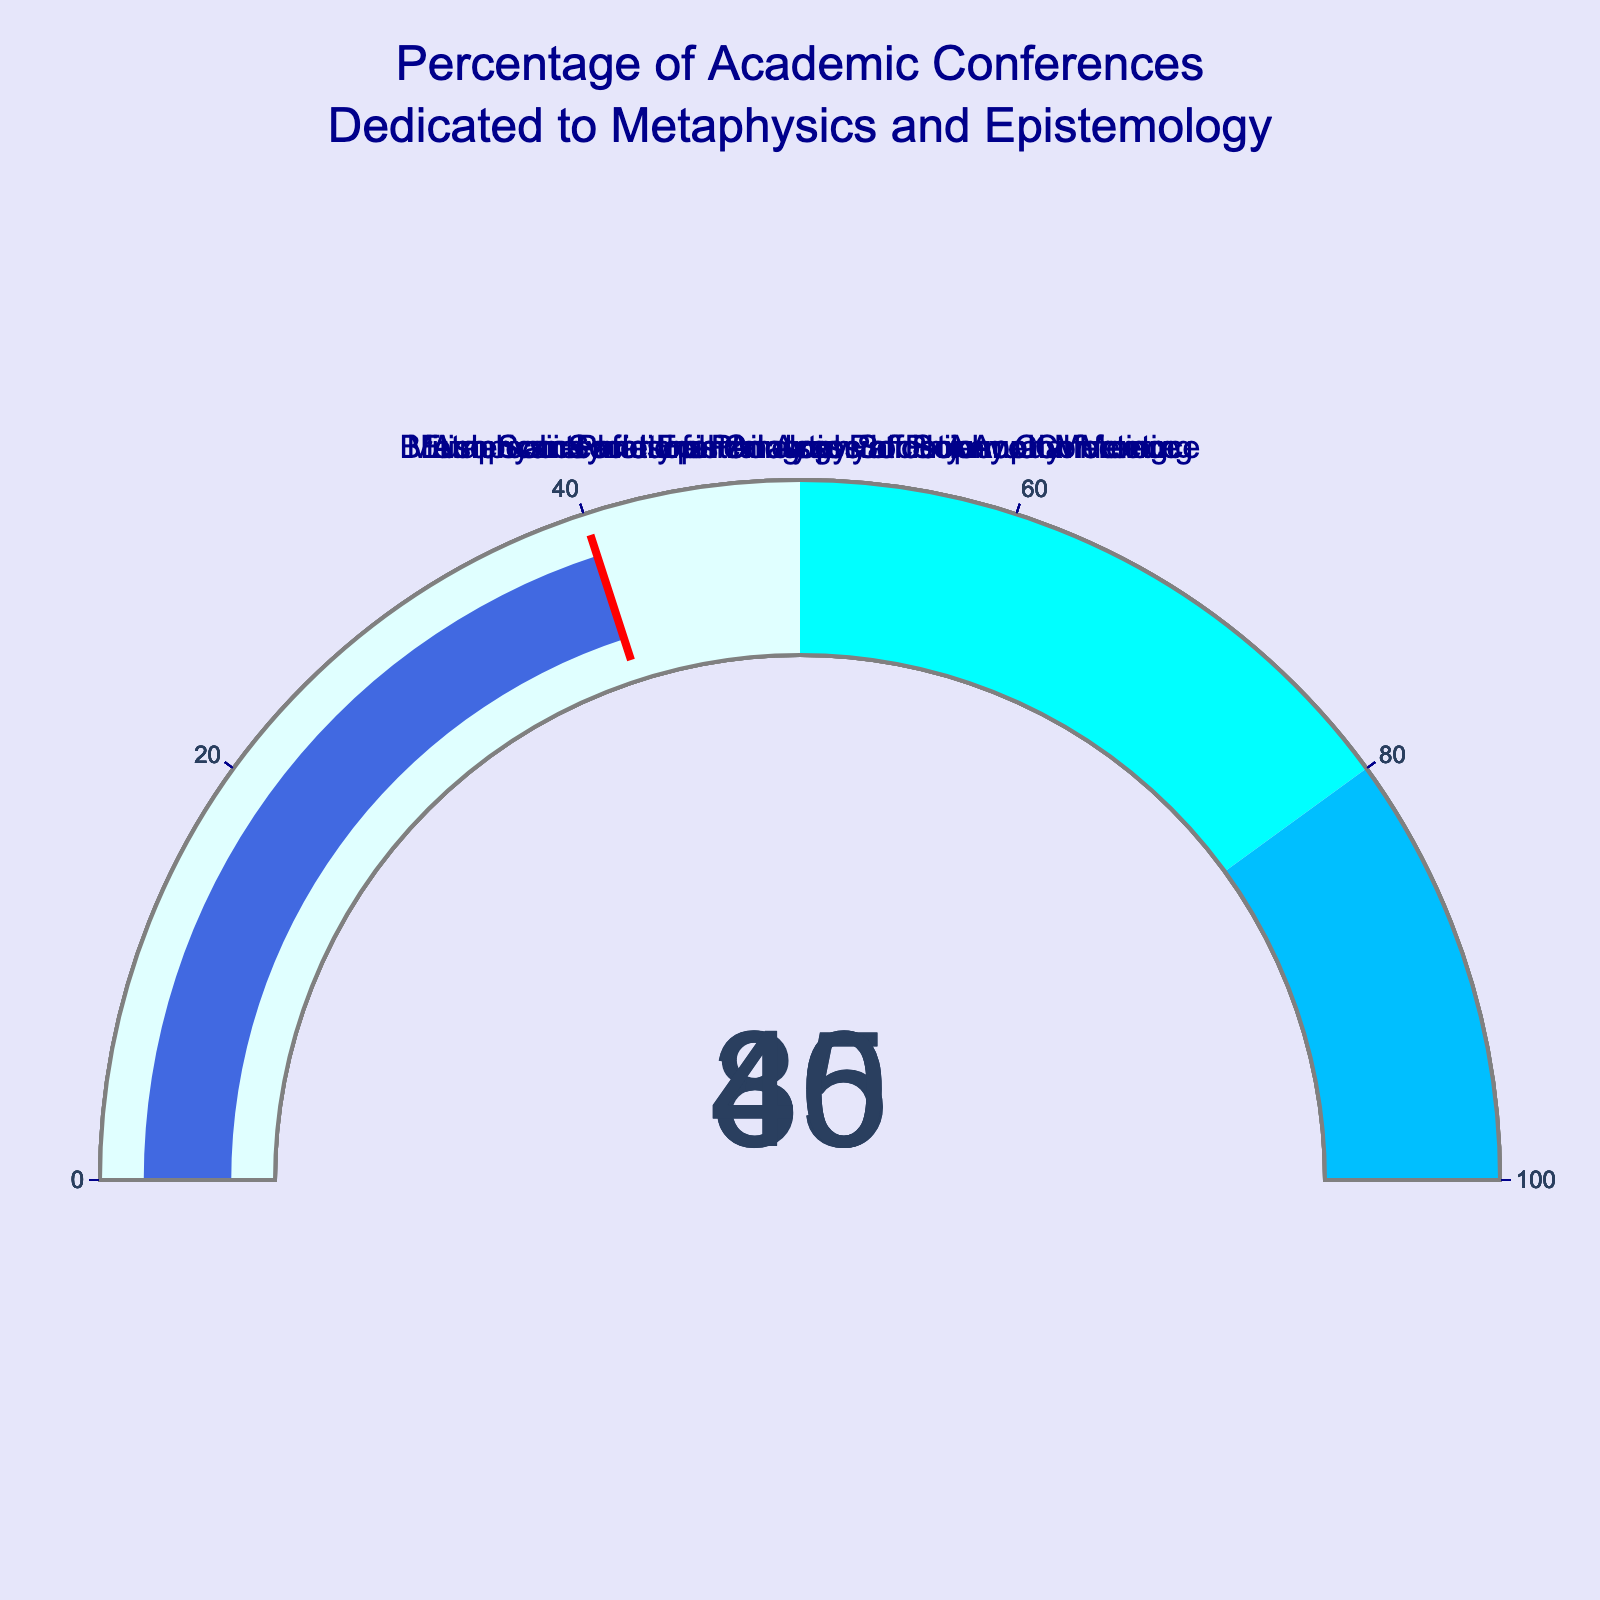Which conference has the highest percentage dedicated to metaphysics and epistemology? To find the answer, look at each gauge and identify the conference with the highest percentage value. The conference is the Metaphysics and Epistemology Society Annual Meeting, which has a gauge value of 80%.
Answer: Metaphysics and Epistemology Society Annual Meeting Which conference has the lowest percentage dedicated to metaphysics and epistemology? Examine each gauge and locate the conference with the lowest percentage value. The American Philosophical Association Annual Meeting has the lowest percentage at 30%.
Answer: American Philosophical Association Annual Meeting What is the difference in percentage between the European Society for Analytic Philosophy Conference and the International Congress of Philosophy? Subtract the percentage of the International Congress of Philosophy (35%) from the percentage of the European Society for Analytic Philosophy Conference (45%).
Answer: 10% What's the average percentage of all the conferences dedicated to metaphysics and epistemology? Add up all the percentages (35% + 80% + 45% + 30% + 40%) to get 230%, then divide by the number of conferences (5) to get the average.
Answer: 46% Which conferences have percentages within the 30% to 40% range? Identify the gauges with values within the 30% to 40% range. The conferences are the International Congress of Philosophy (35%) and the American Philosophical Association Annual Meeting (30%).
Answer: International Congress of Philosophy, American Philosophical Association Annual Meeting Is there any conference with a percentage above 70%? Check each gauge to see if there are any values above 70%. Only the Metaphysics and Epistemology Society Annual Meeting has a percentage above 70%, at 80%.
Answer: Yes How many conferences have a dedicated percentage of 50% or lower? Count the number of gauges with values of 50% or lower: The conferences are the International Congress of Philosophy (35%), European Society for Analytic Philosophy Conference (45%), American Philosophical Association Annual Meeting (30%), and British Society for the Philosophy of Science Conference (40%). Four conferences fall into this category.
Answer: Four Which conference comes closest to being equally dedicated to metaphysics and epistemology without exceeding 50%? Determine which gauge has a value closest to 50% without exceeding it. The European Society for Analytic Philosophy Conference has a value of 45%, making it the closest.
Answer: European Society for Analytic Philosophy Conference 